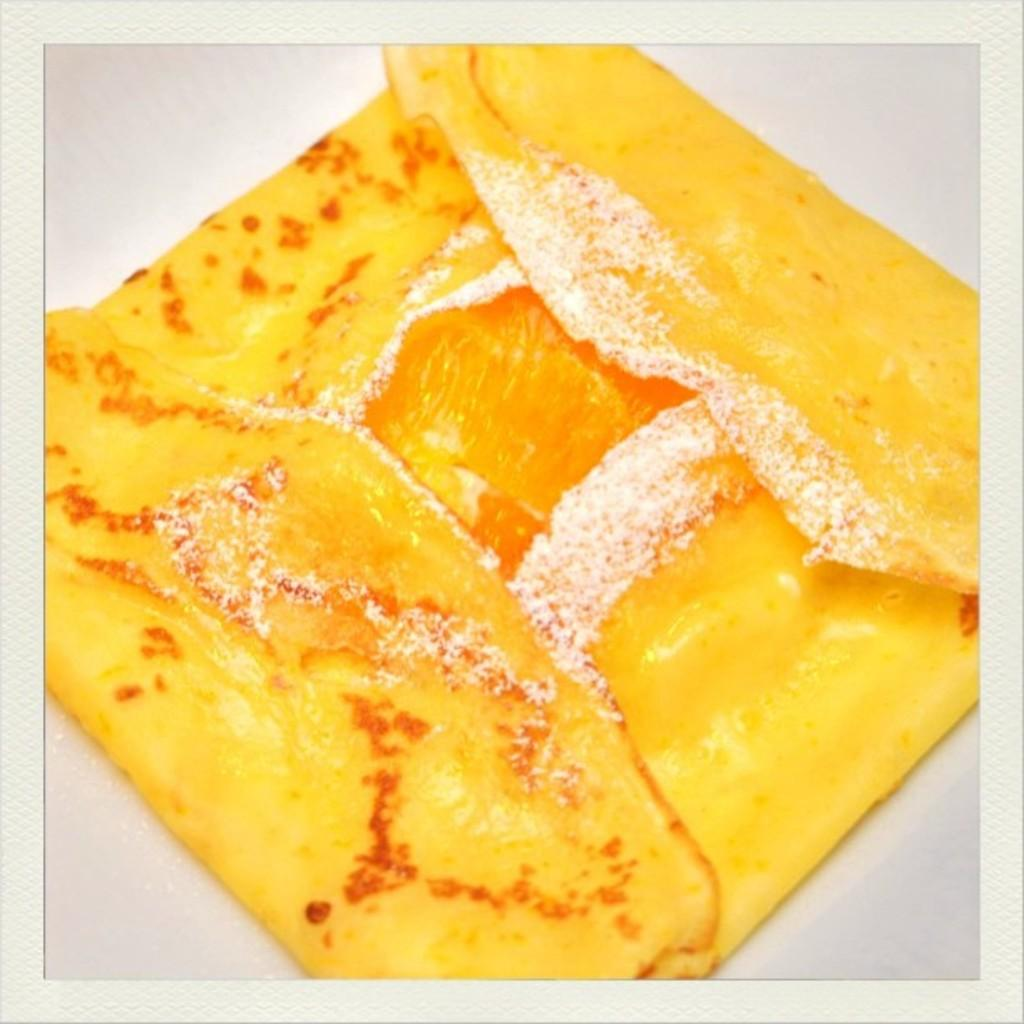What is the main subject of the image? There is a food item in the image. Can you describe the surface on which the food item is placed? The food item is on a white surface. What type of fear can be seen in the image? There is no fear present in the image; it features a food item on a white surface. Can you describe the nest in the image? There is no nest present in the image; it only features a food item on a white surface. 